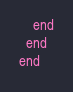Convert code to text. <code><loc_0><loc_0><loc_500><loc_500><_Ruby_>    end
  end
end
</code> 